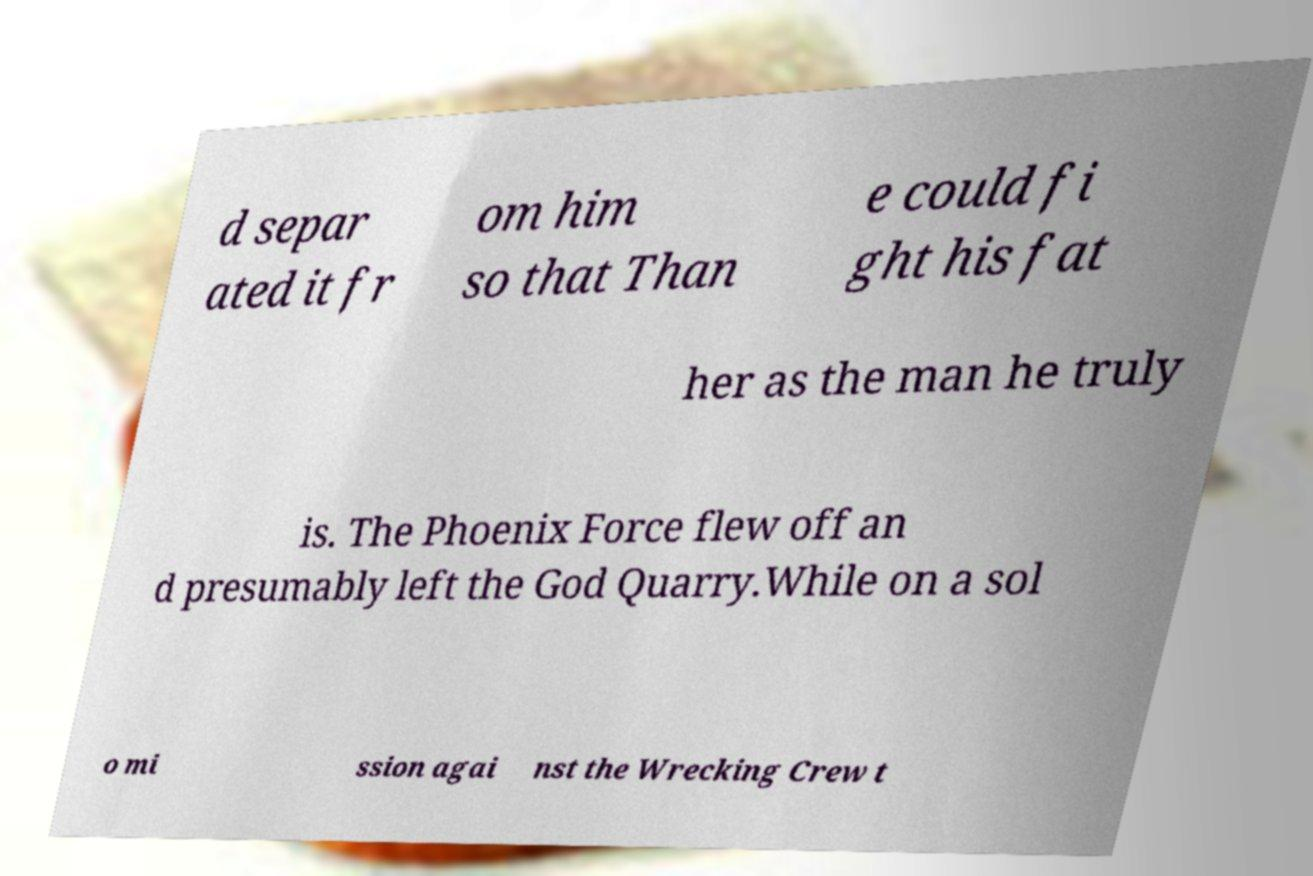Can you read and provide the text displayed in the image?This photo seems to have some interesting text. Can you extract and type it out for me? d separ ated it fr om him so that Than e could fi ght his fat her as the man he truly is. The Phoenix Force flew off an d presumably left the God Quarry.While on a sol o mi ssion agai nst the Wrecking Crew t 